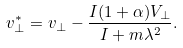Convert formula to latex. <formula><loc_0><loc_0><loc_500><loc_500>v ^ { * } _ { \perp } = v _ { \perp } - \frac { I ( 1 + \alpha ) V _ { \perp } } { I + m \lambda ^ { 2 } } .</formula> 